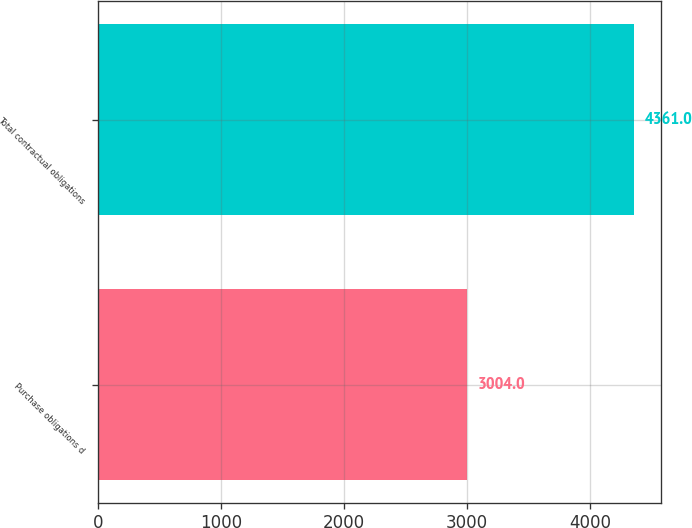Convert chart. <chart><loc_0><loc_0><loc_500><loc_500><bar_chart><fcel>Purchase obligations d<fcel>Total contractual obligations<nl><fcel>3004<fcel>4361<nl></chart> 